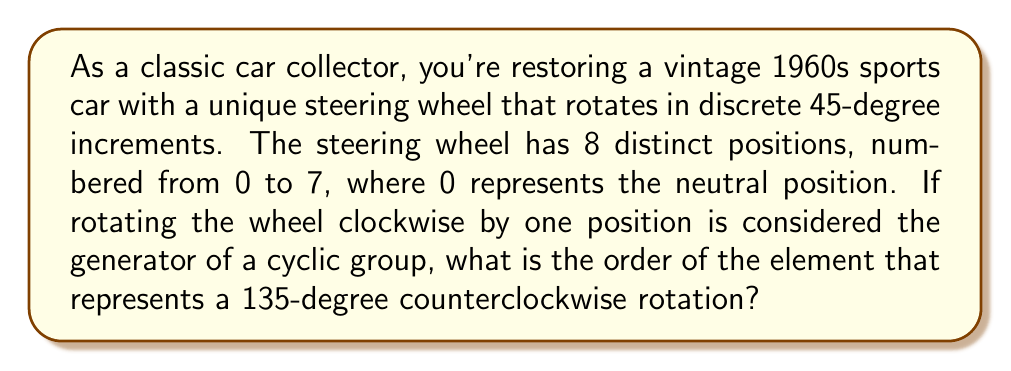Can you answer this question? Let's approach this step-by-step:

1) First, we need to understand the group structure:
   - The steering wheel has 8 positions, so our group has 8 elements.
   - We can represent this as a cyclic group $C_8$ or $\mathbb{Z}_8$.

2) Let's define our generator:
   - Let $a$ represent a 45-degree clockwise rotation.
   - Then $a$ generates the entire group: $\langle a \rangle = C_8$.

3) In cyclic group notation:
   - $a^1$ represents a 45-degree clockwise rotation
   - $a^2$ represents a 90-degree clockwise rotation
   - ...
   - $a^7$ represents a 315-degree clockwise rotation
   - $a^8 = a^0 = e$ (identity element)

4) A counterclockwise rotation can be represented as negative powers of $a$:
   - $a^{-1}$ represents a 45-degree counterclockwise rotation
   - $a^{-2}$ represents a 90-degree counterclockwise rotation
   - $a^{-3}$ represents a 135-degree counterclockwise rotation

5) However, in $C_8$, we can also represent $a^{-3}$ as $a^5$, because:
   $a^{-3} \equiv a^5 \pmod{8}$

6) To find the order of this element, we need to find the smallest positive integer $k$ such that:
   $(a^5)^k = e$

7) This occurs when $5k \equiv 0 \pmod{8}$
   The smallest positive $k$ that satisfies this is $k = 8$.

Therefore, the order of the element representing a 135-degree counterclockwise rotation is 8.
Answer: The order of the element representing a 135-degree counterclockwise rotation is 8. 